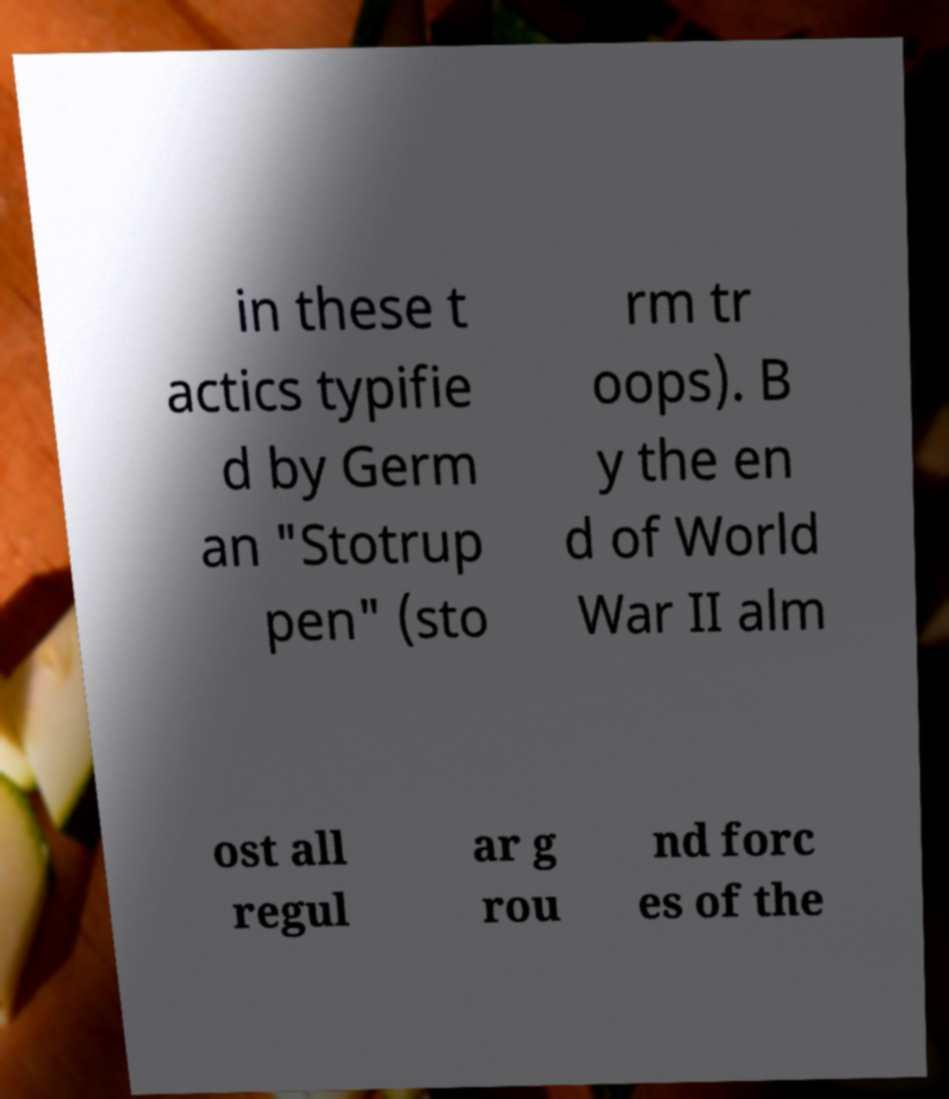I need the written content from this picture converted into text. Can you do that? in these t actics typifie d by Germ an "Stotrup pen" (sto rm tr oops). B y the en d of World War II alm ost all regul ar g rou nd forc es of the 